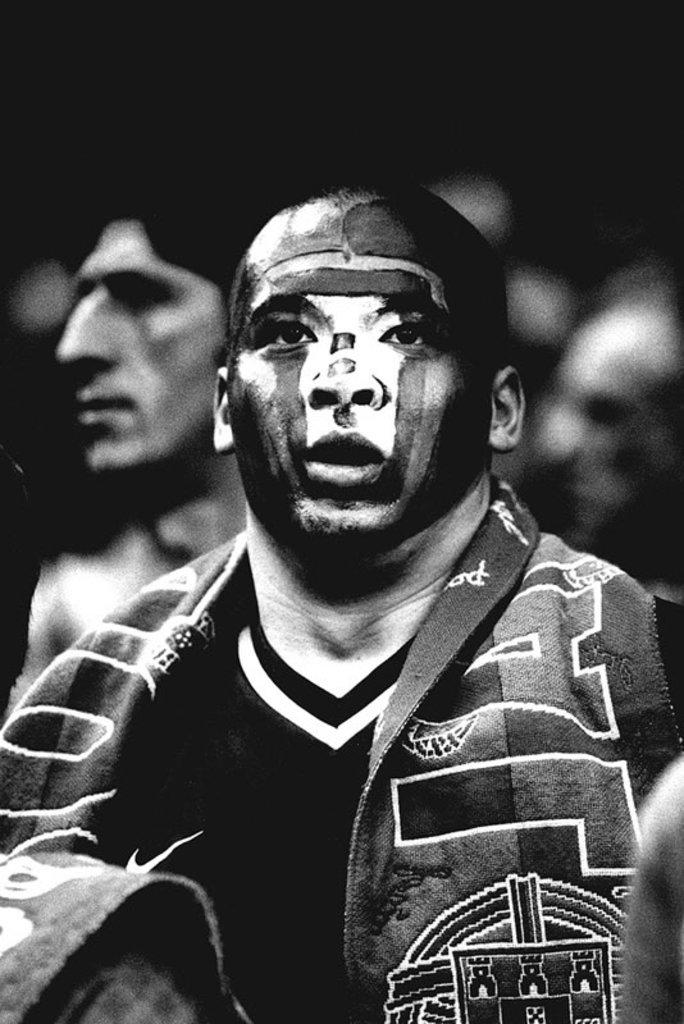What type of picture is in the image? The image contains a black and white picture of a person. Can you describe the background of the image? The background of the image is blurry. What direction is the river flowing in the image? There is no river present in the image. What part of the person's body is visible in the image? The image is black and white, and the person is not clearly visible due to the blurry background, so it is difficult to determine which part of the body is visible. 